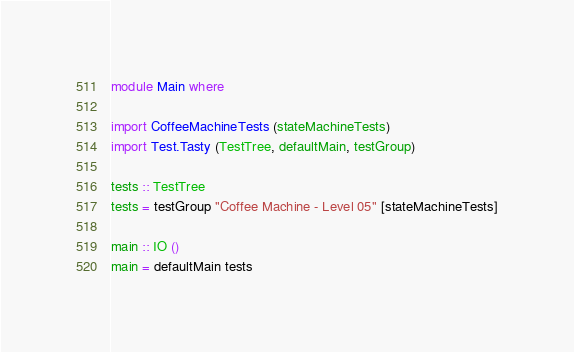Convert code to text. <code><loc_0><loc_0><loc_500><loc_500><_Haskell_>module Main where

import CoffeeMachineTests (stateMachineTests)
import Test.Tasty (TestTree, defaultMain, testGroup)

tests :: TestTree
tests = testGroup "Coffee Machine - Level 05" [stateMachineTests]

main :: IO ()
main = defaultMain tests
</code> 